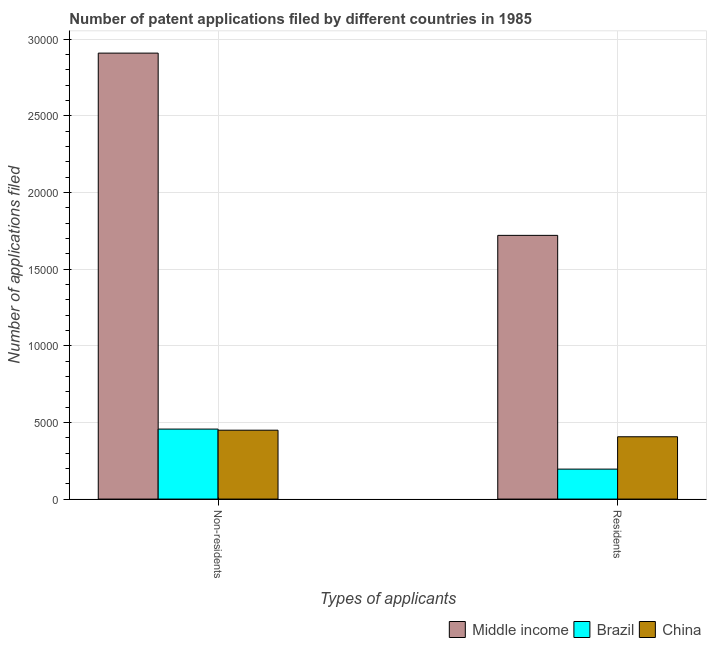How many different coloured bars are there?
Keep it short and to the point. 3. How many groups of bars are there?
Your response must be concise. 2. Are the number of bars per tick equal to the number of legend labels?
Offer a very short reply. Yes. Are the number of bars on each tick of the X-axis equal?
Your response must be concise. Yes. How many bars are there on the 1st tick from the right?
Provide a short and direct response. 3. What is the label of the 2nd group of bars from the left?
Give a very brief answer. Residents. What is the number of patent applications by residents in Middle income?
Ensure brevity in your answer.  1.72e+04. Across all countries, what is the maximum number of patent applications by residents?
Your answer should be very brief. 1.72e+04. Across all countries, what is the minimum number of patent applications by non residents?
Your response must be concise. 4493. In which country was the number of patent applications by residents minimum?
Offer a terse response. Brazil. What is the total number of patent applications by non residents in the graph?
Provide a short and direct response. 3.81e+04. What is the difference between the number of patent applications by non residents in China and that in Middle income?
Make the answer very short. -2.46e+04. What is the difference between the number of patent applications by residents in Brazil and the number of patent applications by non residents in China?
Provide a short and direct response. -2539. What is the average number of patent applications by non residents per country?
Ensure brevity in your answer.  1.27e+04. What is the difference between the number of patent applications by non residents and number of patent applications by residents in China?
Ensure brevity in your answer.  428. In how many countries, is the number of patent applications by non residents greater than 12000 ?
Make the answer very short. 1. What is the ratio of the number of patent applications by residents in Brazil to that in Middle income?
Make the answer very short. 0.11. In how many countries, is the number of patent applications by residents greater than the average number of patent applications by residents taken over all countries?
Provide a succinct answer. 1. What does the 2nd bar from the left in Residents represents?
Offer a very short reply. Brazil. What does the 1st bar from the right in Residents represents?
Ensure brevity in your answer.  China. Are all the bars in the graph horizontal?
Offer a terse response. No. Are the values on the major ticks of Y-axis written in scientific E-notation?
Offer a very short reply. No. Does the graph contain any zero values?
Your response must be concise. No. How are the legend labels stacked?
Offer a very short reply. Horizontal. What is the title of the graph?
Keep it short and to the point. Number of patent applications filed by different countries in 1985. What is the label or title of the X-axis?
Make the answer very short. Types of applicants. What is the label or title of the Y-axis?
Provide a succinct answer. Number of applications filed. What is the Number of applications filed in Middle income in Non-residents?
Your response must be concise. 2.91e+04. What is the Number of applications filed in Brazil in Non-residents?
Provide a succinct answer. 4565. What is the Number of applications filed of China in Non-residents?
Offer a very short reply. 4493. What is the Number of applications filed of Middle income in Residents?
Your answer should be very brief. 1.72e+04. What is the Number of applications filed of Brazil in Residents?
Offer a very short reply. 1954. What is the Number of applications filed in China in Residents?
Your answer should be very brief. 4065. Across all Types of applicants, what is the maximum Number of applications filed in Middle income?
Make the answer very short. 2.91e+04. Across all Types of applicants, what is the maximum Number of applications filed in Brazil?
Provide a short and direct response. 4565. Across all Types of applicants, what is the maximum Number of applications filed in China?
Give a very brief answer. 4493. Across all Types of applicants, what is the minimum Number of applications filed in Middle income?
Offer a very short reply. 1.72e+04. Across all Types of applicants, what is the minimum Number of applications filed of Brazil?
Your answer should be very brief. 1954. Across all Types of applicants, what is the minimum Number of applications filed of China?
Make the answer very short. 4065. What is the total Number of applications filed in Middle income in the graph?
Provide a short and direct response. 4.63e+04. What is the total Number of applications filed in Brazil in the graph?
Make the answer very short. 6519. What is the total Number of applications filed in China in the graph?
Your response must be concise. 8558. What is the difference between the Number of applications filed of Middle income in Non-residents and that in Residents?
Offer a terse response. 1.19e+04. What is the difference between the Number of applications filed in Brazil in Non-residents and that in Residents?
Keep it short and to the point. 2611. What is the difference between the Number of applications filed of China in Non-residents and that in Residents?
Provide a short and direct response. 428. What is the difference between the Number of applications filed of Middle income in Non-residents and the Number of applications filed of Brazil in Residents?
Your response must be concise. 2.71e+04. What is the difference between the Number of applications filed of Middle income in Non-residents and the Number of applications filed of China in Residents?
Provide a short and direct response. 2.50e+04. What is the average Number of applications filed in Middle income per Types of applicants?
Offer a very short reply. 2.31e+04. What is the average Number of applications filed in Brazil per Types of applicants?
Provide a short and direct response. 3259.5. What is the average Number of applications filed of China per Types of applicants?
Your response must be concise. 4279. What is the difference between the Number of applications filed in Middle income and Number of applications filed in Brazil in Non-residents?
Keep it short and to the point. 2.45e+04. What is the difference between the Number of applications filed of Middle income and Number of applications filed of China in Non-residents?
Your answer should be compact. 2.46e+04. What is the difference between the Number of applications filed in Middle income and Number of applications filed in Brazil in Residents?
Provide a succinct answer. 1.52e+04. What is the difference between the Number of applications filed in Middle income and Number of applications filed in China in Residents?
Keep it short and to the point. 1.31e+04. What is the difference between the Number of applications filed of Brazil and Number of applications filed of China in Residents?
Keep it short and to the point. -2111. What is the ratio of the Number of applications filed in Middle income in Non-residents to that in Residents?
Offer a terse response. 1.69. What is the ratio of the Number of applications filed of Brazil in Non-residents to that in Residents?
Keep it short and to the point. 2.34. What is the ratio of the Number of applications filed in China in Non-residents to that in Residents?
Give a very brief answer. 1.11. What is the difference between the highest and the second highest Number of applications filed of Middle income?
Offer a very short reply. 1.19e+04. What is the difference between the highest and the second highest Number of applications filed of Brazil?
Make the answer very short. 2611. What is the difference between the highest and the second highest Number of applications filed in China?
Keep it short and to the point. 428. What is the difference between the highest and the lowest Number of applications filed in Middle income?
Ensure brevity in your answer.  1.19e+04. What is the difference between the highest and the lowest Number of applications filed of Brazil?
Your answer should be compact. 2611. What is the difference between the highest and the lowest Number of applications filed of China?
Make the answer very short. 428. 